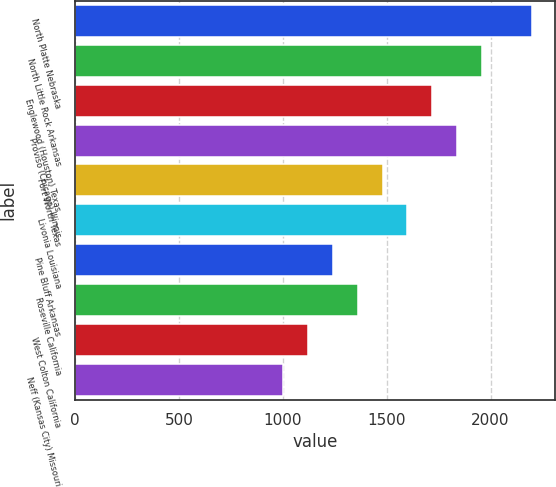<chart> <loc_0><loc_0><loc_500><loc_500><bar_chart><fcel>North Platte Nebraska<fcel>North Little Rock Arkansas<fcel>Englewood (Houston) Texas<fcel>Proviso (Chicago) Illinois<fcel>Fort Worth Texas<fcel>Livonia Louisiana<fcel>Pine Bluff Arkansas<fcel>Roseville California<fcel>West Colton California<fcel>Neff (Kansas City) Missouri<nl><fcel>2200<fcel>1960<fcel>1720<fcel>1840<fcel>1480<fcel>1600<fcel>1240<fcel>1360<fcel>1120<fcel>1000<nl></chart> 